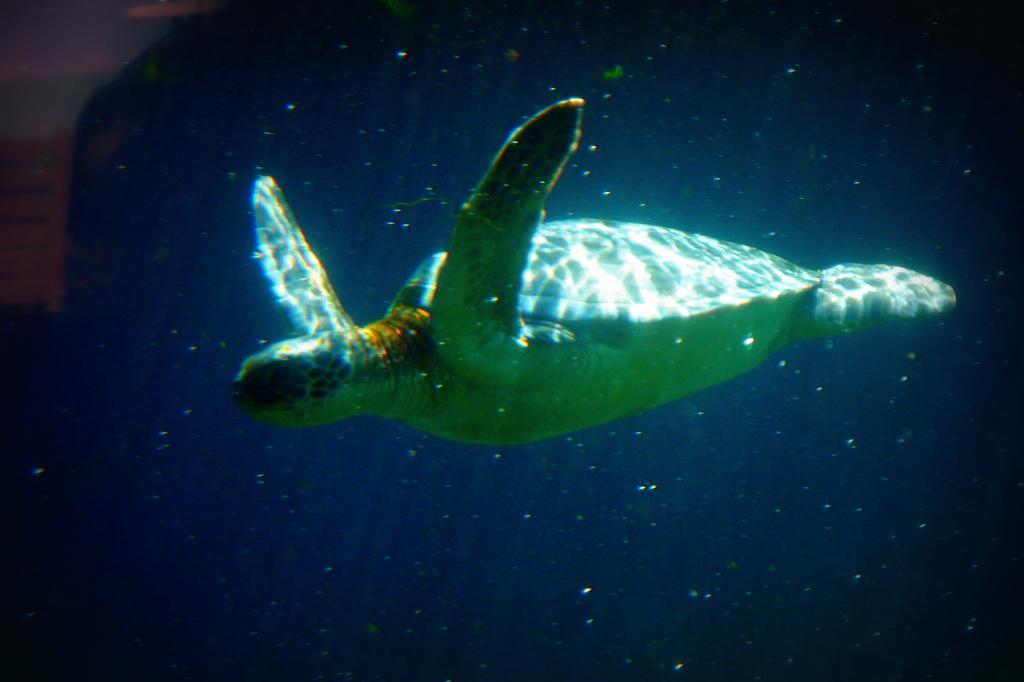Could you give a brief overview of what you see in this image? In this image I can see a tortoise in the water. 